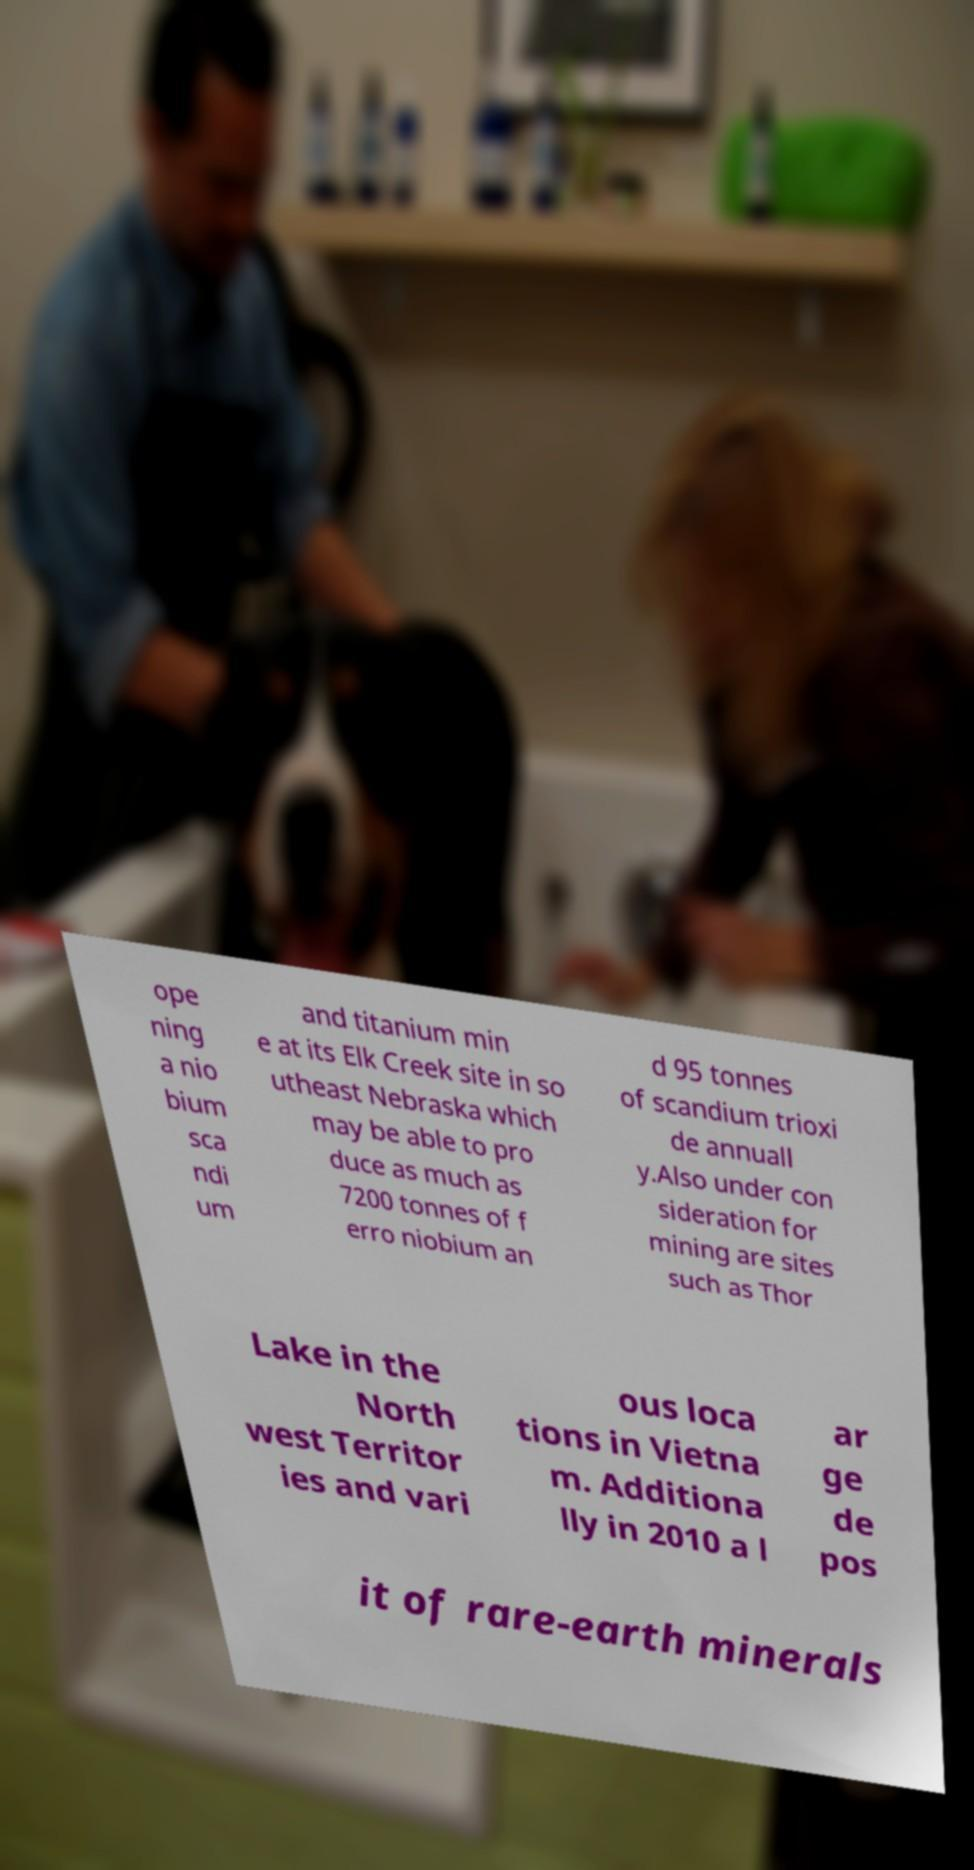Could you assist in decoding the text presented in this image and type it out clearly? ope ning a nio bium sca ndi um and titanium min e at its Elk Creek site in so utheast Nebraska which may be able to pro duce as much as 7200 tonnes of f erro niobium an d 95 tonnes of scandium trioxi de annuall y.Also under con sideration for mining are sites such as Thor Lake in the North west Territor ies and vari ous loca tions in Vietna m. Additiona lly in 2010 a l ar ge de pos it of rare-earth minerals 